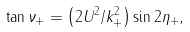<formula> <loc_0><loc_0><loc_500><loc_500>\tan \nu _ { + } = \left ( 2 U ^ { 2 } / k _ { + } ^ { 2 } \right ) \sin 2 \eta _ { + } ,</formula> 